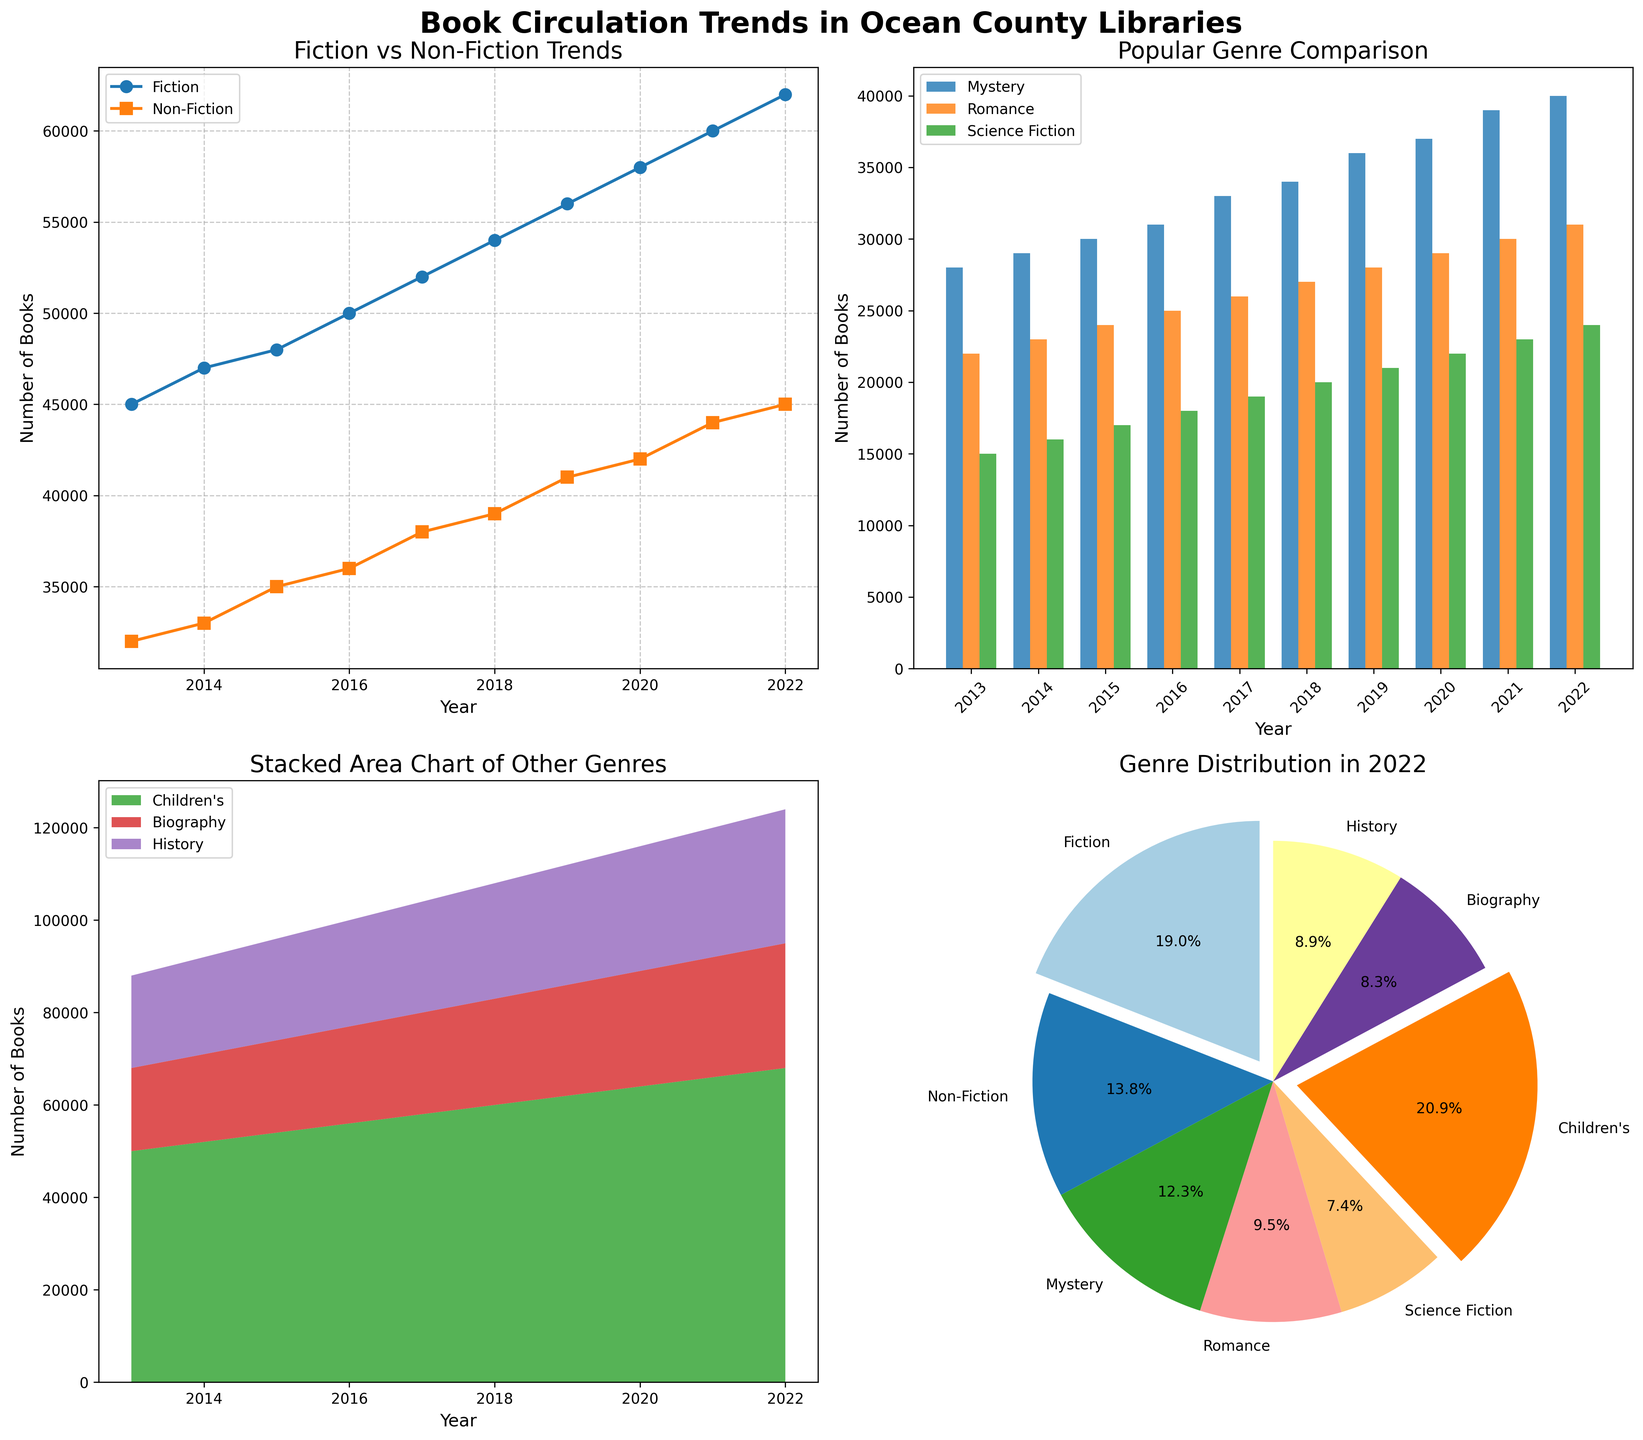Which genres are compared in the top left line plot of the figure? The top left line plot compares the genres 'Fiction' and 'Non-Fiction' over the years from 2013 to 2022. This can be identified by the legend labels 'Fiction' and 'Non-Fiction' beside the plot.
Answer: Fiction and Non-Fiction What is the title of the bar plot depicted in the top right section of the figure? The title of the bar plot is displayed at the top of the plot. It reads "Popular Genre Comparison," indicating that the plot compares the circulation trends of multiple popular genres.
Answer: Popular Genre Comparison How has the circulation of Children's books changed from 2013 to 2022? By analyzing the stacked area plot in the bottom left section, we observe the trend line for Children's books, which consistently increases from approximately 50,000 in 2013 to about 68,000 in 2022.
Answer: Increased by 18,000 Which year shows the highest total circulation for Fiction and Non-Fiction combined based on the line plot? By examining the top left line plot, we can see that 2022 has the highest combined circulation for Fiction and Non-Fiction. The values are approximately 62,000 for Fiction and 45,000 for Non-Fiction, totaling 107,000.
Answer: 2022 Which genre has the smallest proportion in the pie chart for the year 2022? The pie chart in the bottom right section shows the distribution of genres in 2022. By comparing segment sizes, we see that Science Fiction has the smallest proportion in the chart.
Answer: Science Fiction Which year saw the largest increase in Mystery book circulation compared to the previous year? Analyzing the bar plot in the top right section, we observe that the largest annual increase in Mystery circulation occurs between 2020 and 2021, where it increases from approximately 37,000 to 39,000.
Answer: 2021 How do Romance and Mystery circulation trends compare from 2013 to 2022? By looking at the trends in the bar plot in the top right and comparing the bars for Romance and Mystery, we can see that both genres have shown steady increases. Mystery starts slightly higher in 2013 and maintains a parallel upward trend with Romance.
Answer: Both increased steadily; Mystery started slightly higher What's the overall distribution of genres in 2022 according to the pie chart? By looking at the pie chart, we observe the proportions of genres in 2022. Children's books dominate the distribution, followed by Fiction. Other genres like Mystery, Romance, Science Fiction, Biography, and History have smaller shares.
Answer: Children's books dominate, followed by Fiction 